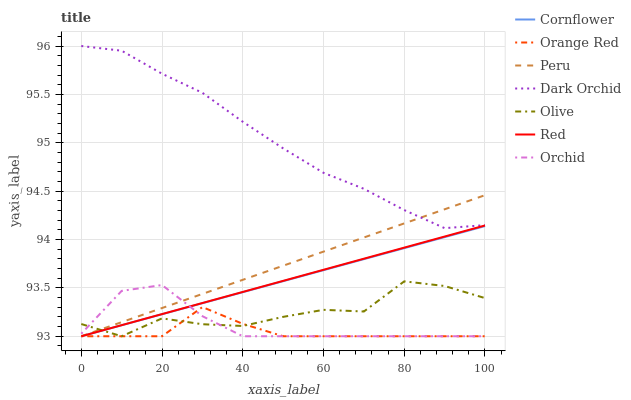Does Orange Red have the minimum area under the curve?
Answer yes or no. Yes. Does Dark Orchid have the maximum area under the curve?
Answer yes or no. Yes. Does Peru have the minimum area under the curve?
Answer yes or no. No. Does Peru have the maximum area under the curve?
Answer yes or no. No. Is Cornflower the smoothest?
Answer yes or no. Yes. Is Olive the roughest?
Answer yes or no. Yes. Is Dark Orchid the smoothest?
Answer yes or no. No. Is Dark Orchid the roughest?
Answer yes or no. No. Does Cornflower have the lowest value?
Answer yes or no. Yes. Does Dark Orchid have the lowest value?
Answer yes or no. No. Does Dark Orchid have the highest value?
Answer yes or no. Yes. Does Peru have the highest value?
Answer yes or no. No. Is Olive less than Dark Orchid?
Answer yes or no. Yes. Is Dark Orchid greater than Orange Red?
Answer yes or no. Yes. Does Peru intersect Cornflower?
Answer yes or no. Yes. Is Peru less than Cornflower?
Answer yes or no. No. Is Peru greater than Cornflower?
Answer yes or no. No. Does Olive intersect Dark Orchid?
Answer yes or no. No. 